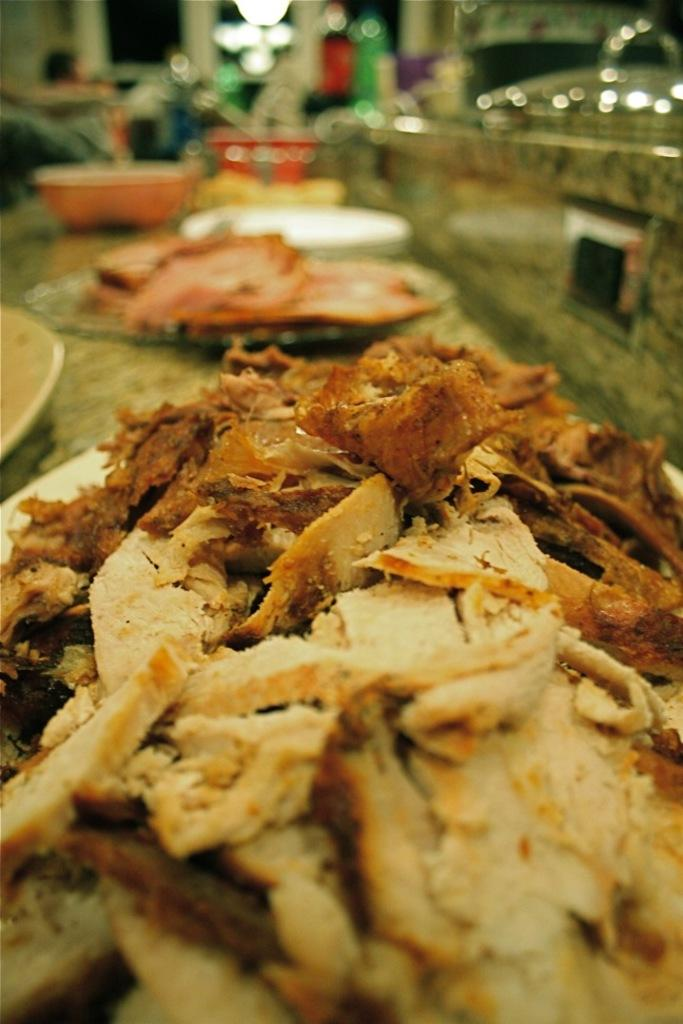What is present on the plates in the image? There are plates with food in the image. What other types of dishes can be seen in the image? There are bowls in the image. What can be used for illumination in the image? There are lights visible in the image. How would you describe the background of the image? The background of the image is blurred. What day of the week is it in the image? The day of the week cannot be determined from the image, as it does not contain any information about the date or time. 